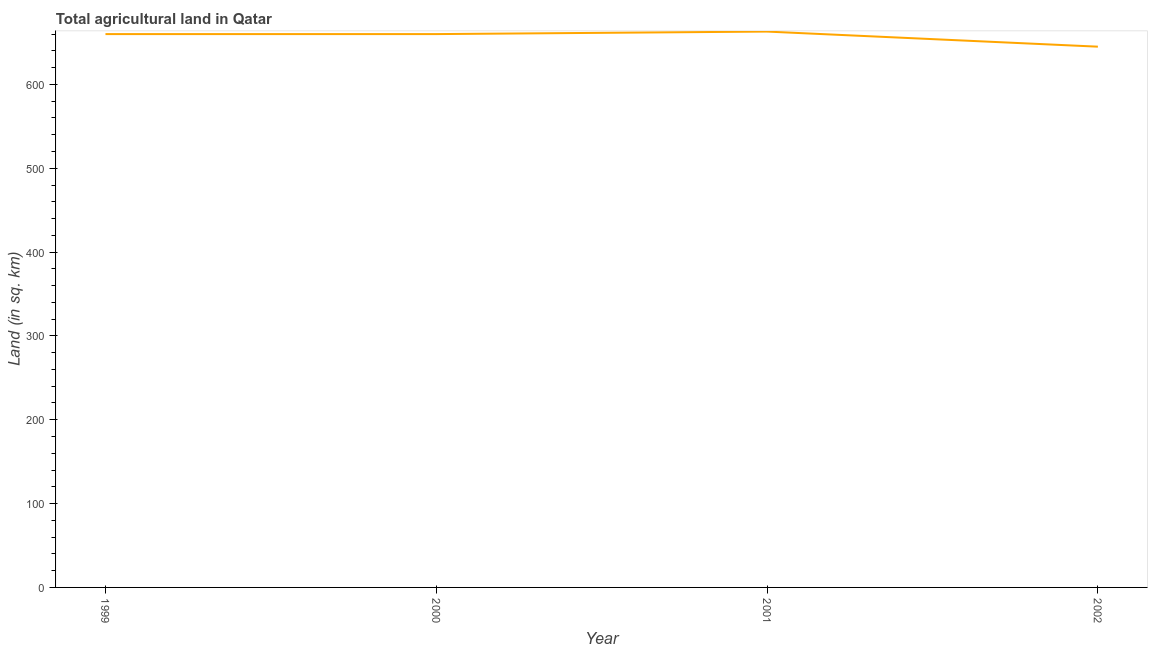What is the agricultural land in 1999?
Provide a short and direct response. 660. Across all years, what is the maximum agricultural land?
Keep it short and to the point. 663. Across all years, what is the minimum agricultural land?
Keep it short and to the point. 645. What is the sum of the agricultural land?
Give a very brief answer. 2628. What is the difference between the agricultural land in 1999 and 2002?
Give a very brief answer. 15. What is the average agricultural land per year?
Offer a terse response. 657. What is the median agricultural land?
Offer a very short reply. 660. What is the ratio of the agricultural land in 1999 to that in 2002?
Offer a very short reply. 1.02. Is the agricultural land in 2000 less than that in 2002?
Offer a very short reply. No. Is the difference between the agricultural land in 2000 and 2001 greater than the difference between any two years?
Offer a very short reply. No. In how many years, is the agricultural land greater than the average agricultural land taken over all years?
Offer a very short reply. 3. Does the agricultural land monotonically increase over the years?
Make the answer very short. No. How many lines are there?
Your answer should be very brief. 1. How many years are there in the graph?
Your response must be concise. 4. Does the graph contain any zero values?
Your answer should be compact. No. What is the title of the graph?
Offer a terse response. Total agricultural land in Qatar. What is the label or title of the X-axis?
Your answer should be compact. Year. What is the label or title of the Y-axis?
Provide a short and direct response. Land (in sq. km). What is the Land (in sq. km) in 1999?
Make the answer very short. 660. What is the Land (in sq. km) in 2000?
Provide a short and direct response. 660. What is the Land (in sq. km) in 2001?
Make the answer very short. 663. What is the Land (in sq. km) in 2002?
Offer a very short reply. 645. What is the difference between the Land (in sq. km) in 1999 and 2000?
Your answer should be very brief. 0. What is the difference between the Land (in sq. km) in 1999 and 2001?
Provide a short and direct response. -3. What is the difference between the Land (in sq. km) in 1999 and 2002?
Offer a terse response. 15. What is the difference between the Land (in sq. km) in 2000 and 2001?
Offer a terse response. -3. What is the difference between the Land (in sq. km) in 2001 and 2002?
Give a very brief answer. 18. What is the ratio of the Land (in sq. km) in 1999 to that in 2001?
Give a very brief answer. 0.99. What is the ratio of the Land (in sq. km) in 2001 to that in 2002?
Ensure brevity in your answer.  1.03. 